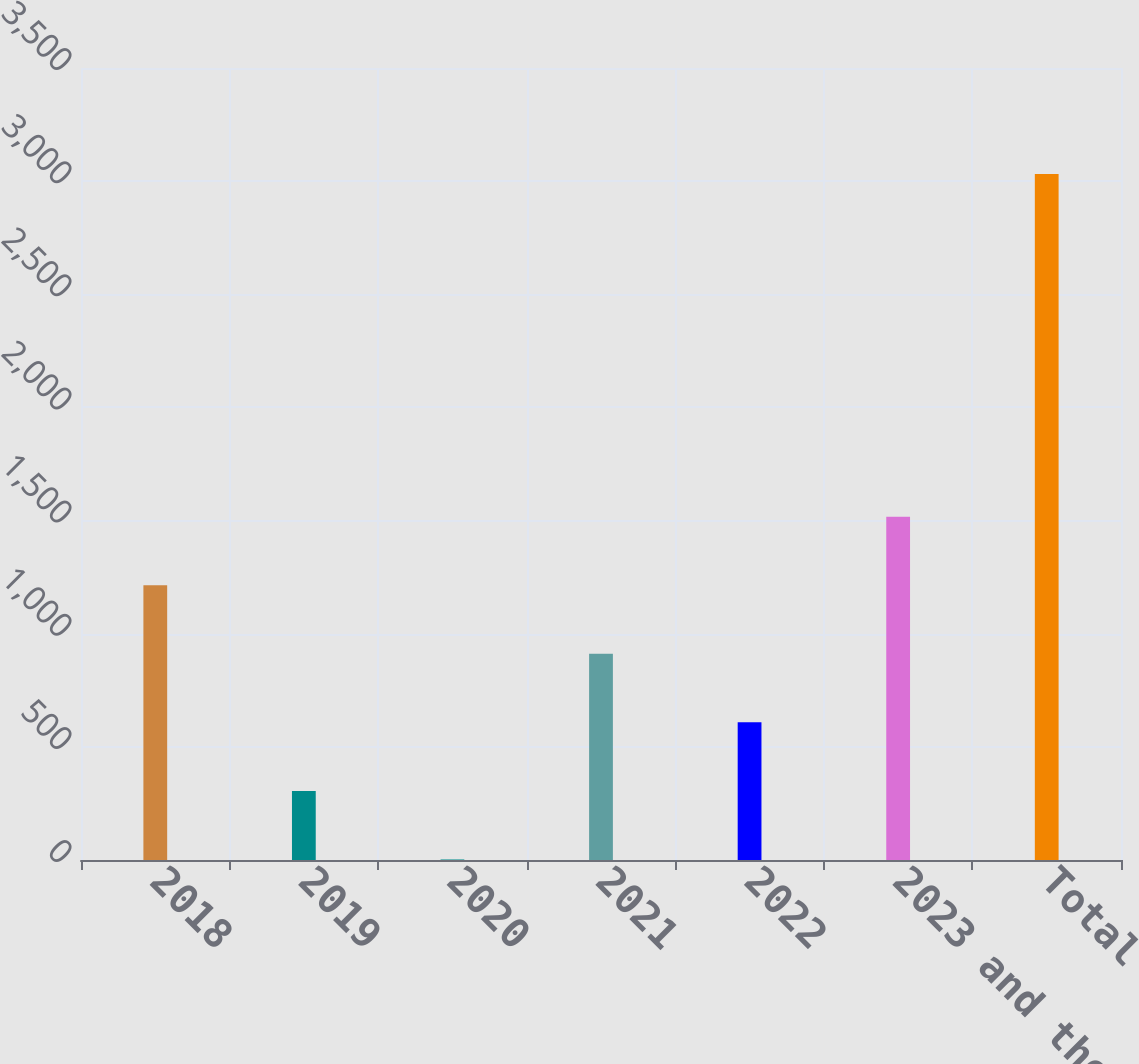<chart> <loc_0><loc_0><loc_500><loc_500><bar_chart><fcel>2018<fcel>2019<fcel>2020<fcel>2021<fcel>2022<fcel>2023 and thereafter<fcel>Total<nl><fcel>1214.18<fcel>305.27<fcel>2.3<fcel>911.21<fcel>608.24<fcel>1517.15<fcel>3032<nl></chart> 